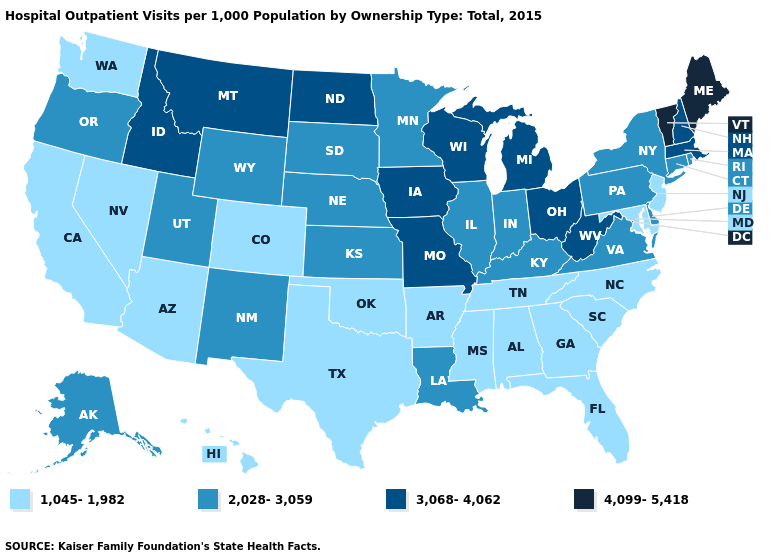How many symbols are there in the legend?
Concise answer only. 4. Which states have the lowest value in the South?
Answer briefly. Alabama, Arkansas, Florida, Georgia, Maryland, Mississippi, North Carolina, Oklahoma, South Carolina, Tennessee, Texas. Name the states that have a value in the range 3,068-4,062?
Give a very brief answer. Idaho, Iowa, Massachusetts, Michigan, Missouri, Montana, New Hampshire, North Dakota, Ohio, West Virginia, Wisconsin. Which states have the lowest value in the MidWest?
Short answer required. Illinois, Indiana, Kansas, Minnesota, Nebraska, South Dakota. What is the value of South Dakota?
Be succinct. 2,028-3,059. Among the states that border Texas , which have the highest value?
Keep it brief. Louisiana, New Mexico. What is the value of Ohio?
Be succinct. 3,068-4,062. What is the lowest value in the West?
Concise answer only. 1,045-1,982. Is the legend a continuous bar?
Quick response, please. No. What is the value of Illinois?
Be succinct. 2,028-3,059. Does New Hampshire have a lower value than Vermont?
Short answer required. Yes. Name the states that have a value in the range 3,068-4,062?
Concise answer only. Idaho, Iowa, Massachusetts, Michigan, Missouri, Montana, New Hampshire, North Dakota, Ohio, West Virginia, Wisconsin. Does West Virginia have a lower value than Vermont?
Quick response, please. Yes. Does the first symbol in the legend represent the smallest category?
Be succinct. Yes. Among the states that border Massachusetts , which have the lowest value?
Short answer required. Connecticut, New York, Rhode Island. 